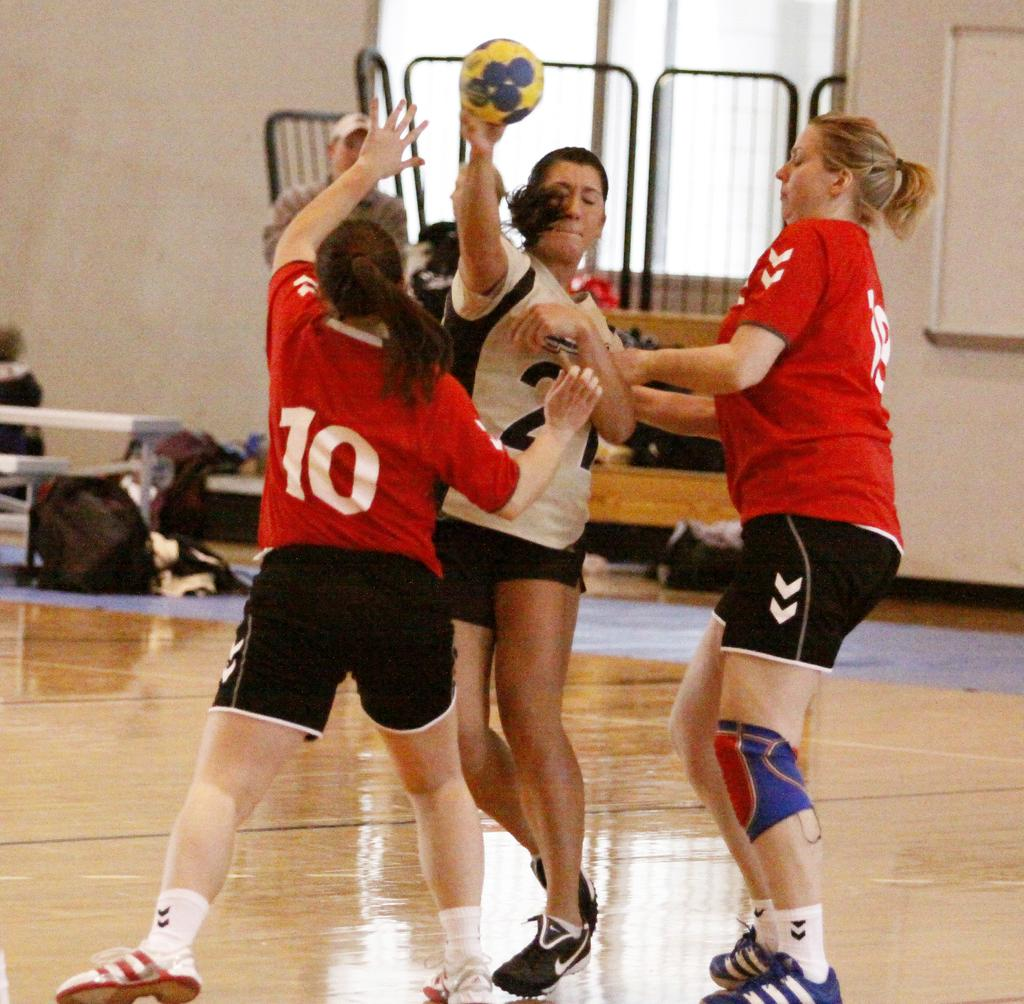What are the persons in the image doing? The persons in the image are standing on the floor. What is one of the persons holding? One of the persons is holding a ball in their hands. What can be seen in the background of the image? In the background of the image, there are grills, bags on benches, and bags on the floor. What type of metal is the island made of in the image? There is no island present in the image, so it is not possible to determine what type of metal it might be made of. 